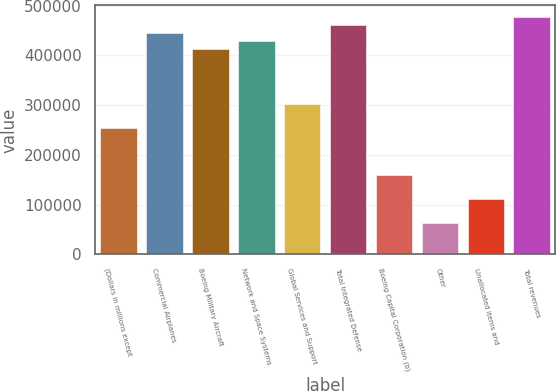Convert chart. <chart><loc_0><loc_0><loc_500><loc_500><bar_chart><fcel>(Dollars in millions except<fcel>Commercial Airplanes<fcel>Boeing Military Aircraft<fcel>Network and Space Systems<fcel>Global Services and Support<fcel>Total Integrated Defense<fcel>Boeing Capital Corporation (b)<fcel>Other<fcel>Unallocated items and<fcel>Total revenues<nl><fcel>254400<fcel>445198<fcel>413399<fcel>429299<fcel>302099<fcel>461098<fcel>159000<fcel>63600.5<fcel>111300<fcel>476998<nl></chart> 